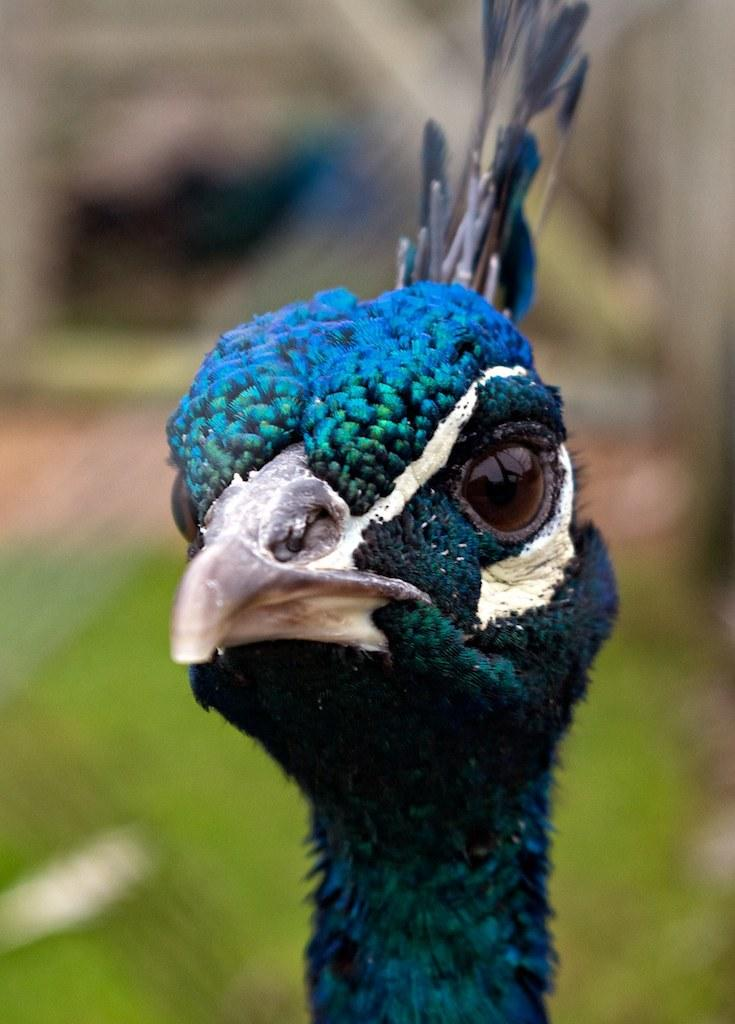What type of animal is in the image? There is a peacock in the image. Can you describe the background of the image? The background of the image is blurred. How many children are playing with the liquid in the image? There are no children or liquid present in the image; it features a peacock with a blurred background. 